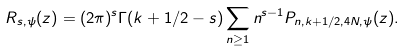<formula> <loc_0><loc_0><loc_500><loc_500>R _ { s , \psi } ( z ) = ( 2 \pi ) ^ { s } \Gamma ( k + 1 / 2 - s ) \sum _ { n \geq 1 } n ^ { s - 1 } P _ { n , k + 1 / 2 , 4 N , \psi } ( z ) .</formula> 